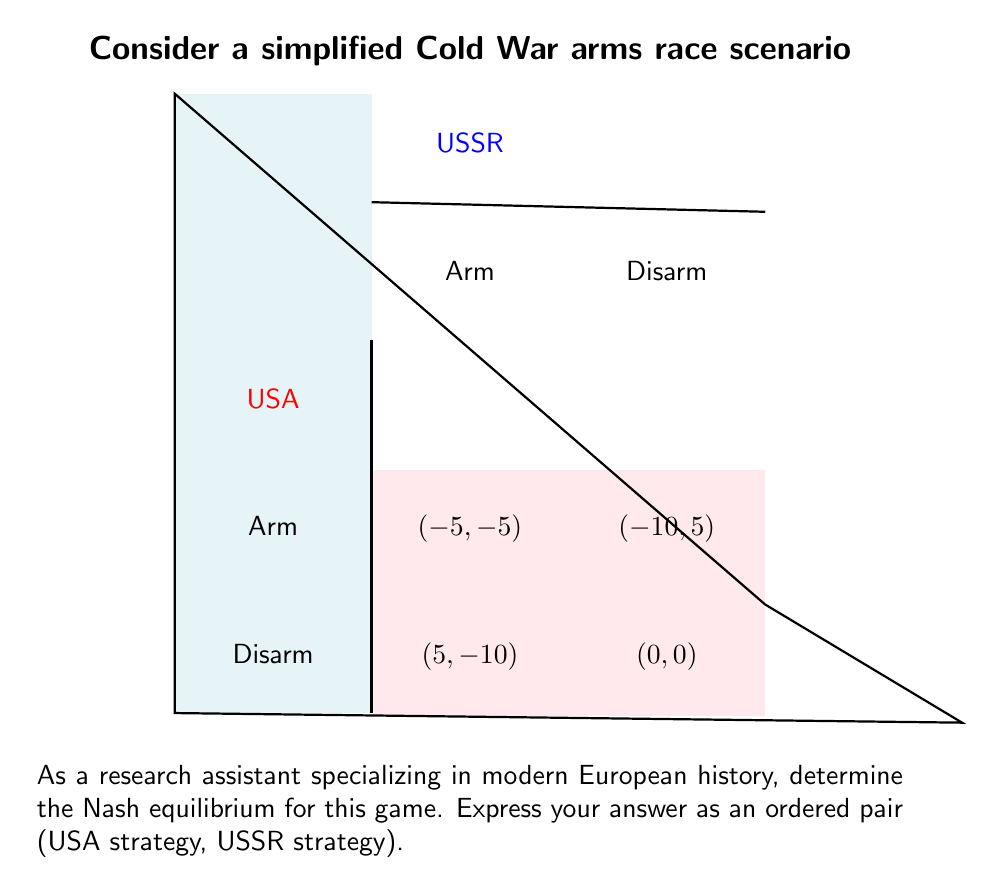Could you help me with this problem? To determine the Nash equilibrium, we need to analyze each player's best response to the other player's strategy:

1. USA's perspective:
   - If USSR arms: USA's best response is to arm (-5 > -10)
   - If USSR disarms: USA's best response is to arm (5 > 0)

2. USSR's perspective:
   - If USA arms: USSR's best response is to arm (-5 > -10)
   - If USA disarms: USSR's best response is to arm (5 > 0)

3. Nash equilibrium definition:
   A Nash equilibrium occurs when each player's strategy is the best response to the other player's strategy.

4. Identifying the Nash equilibrium:
   - Both players have a dominant strategy to "Arm"
   - Neither player has an incentive to unilaterally change their strategy

5. Historical context:
   This simplified model reflects the strategic dilemma faced by the USA and USSR during the Cold War. The Nash equilibrium of (Arm, Arm) aligns with the historical arms race that occurred, as neither side was willing to disarm unilaterally due to the potential strategic disadvantage.

Therefore, the Nash equilibrium for this game is (Arm, Arm).
Answer: (Arm, Arm) 